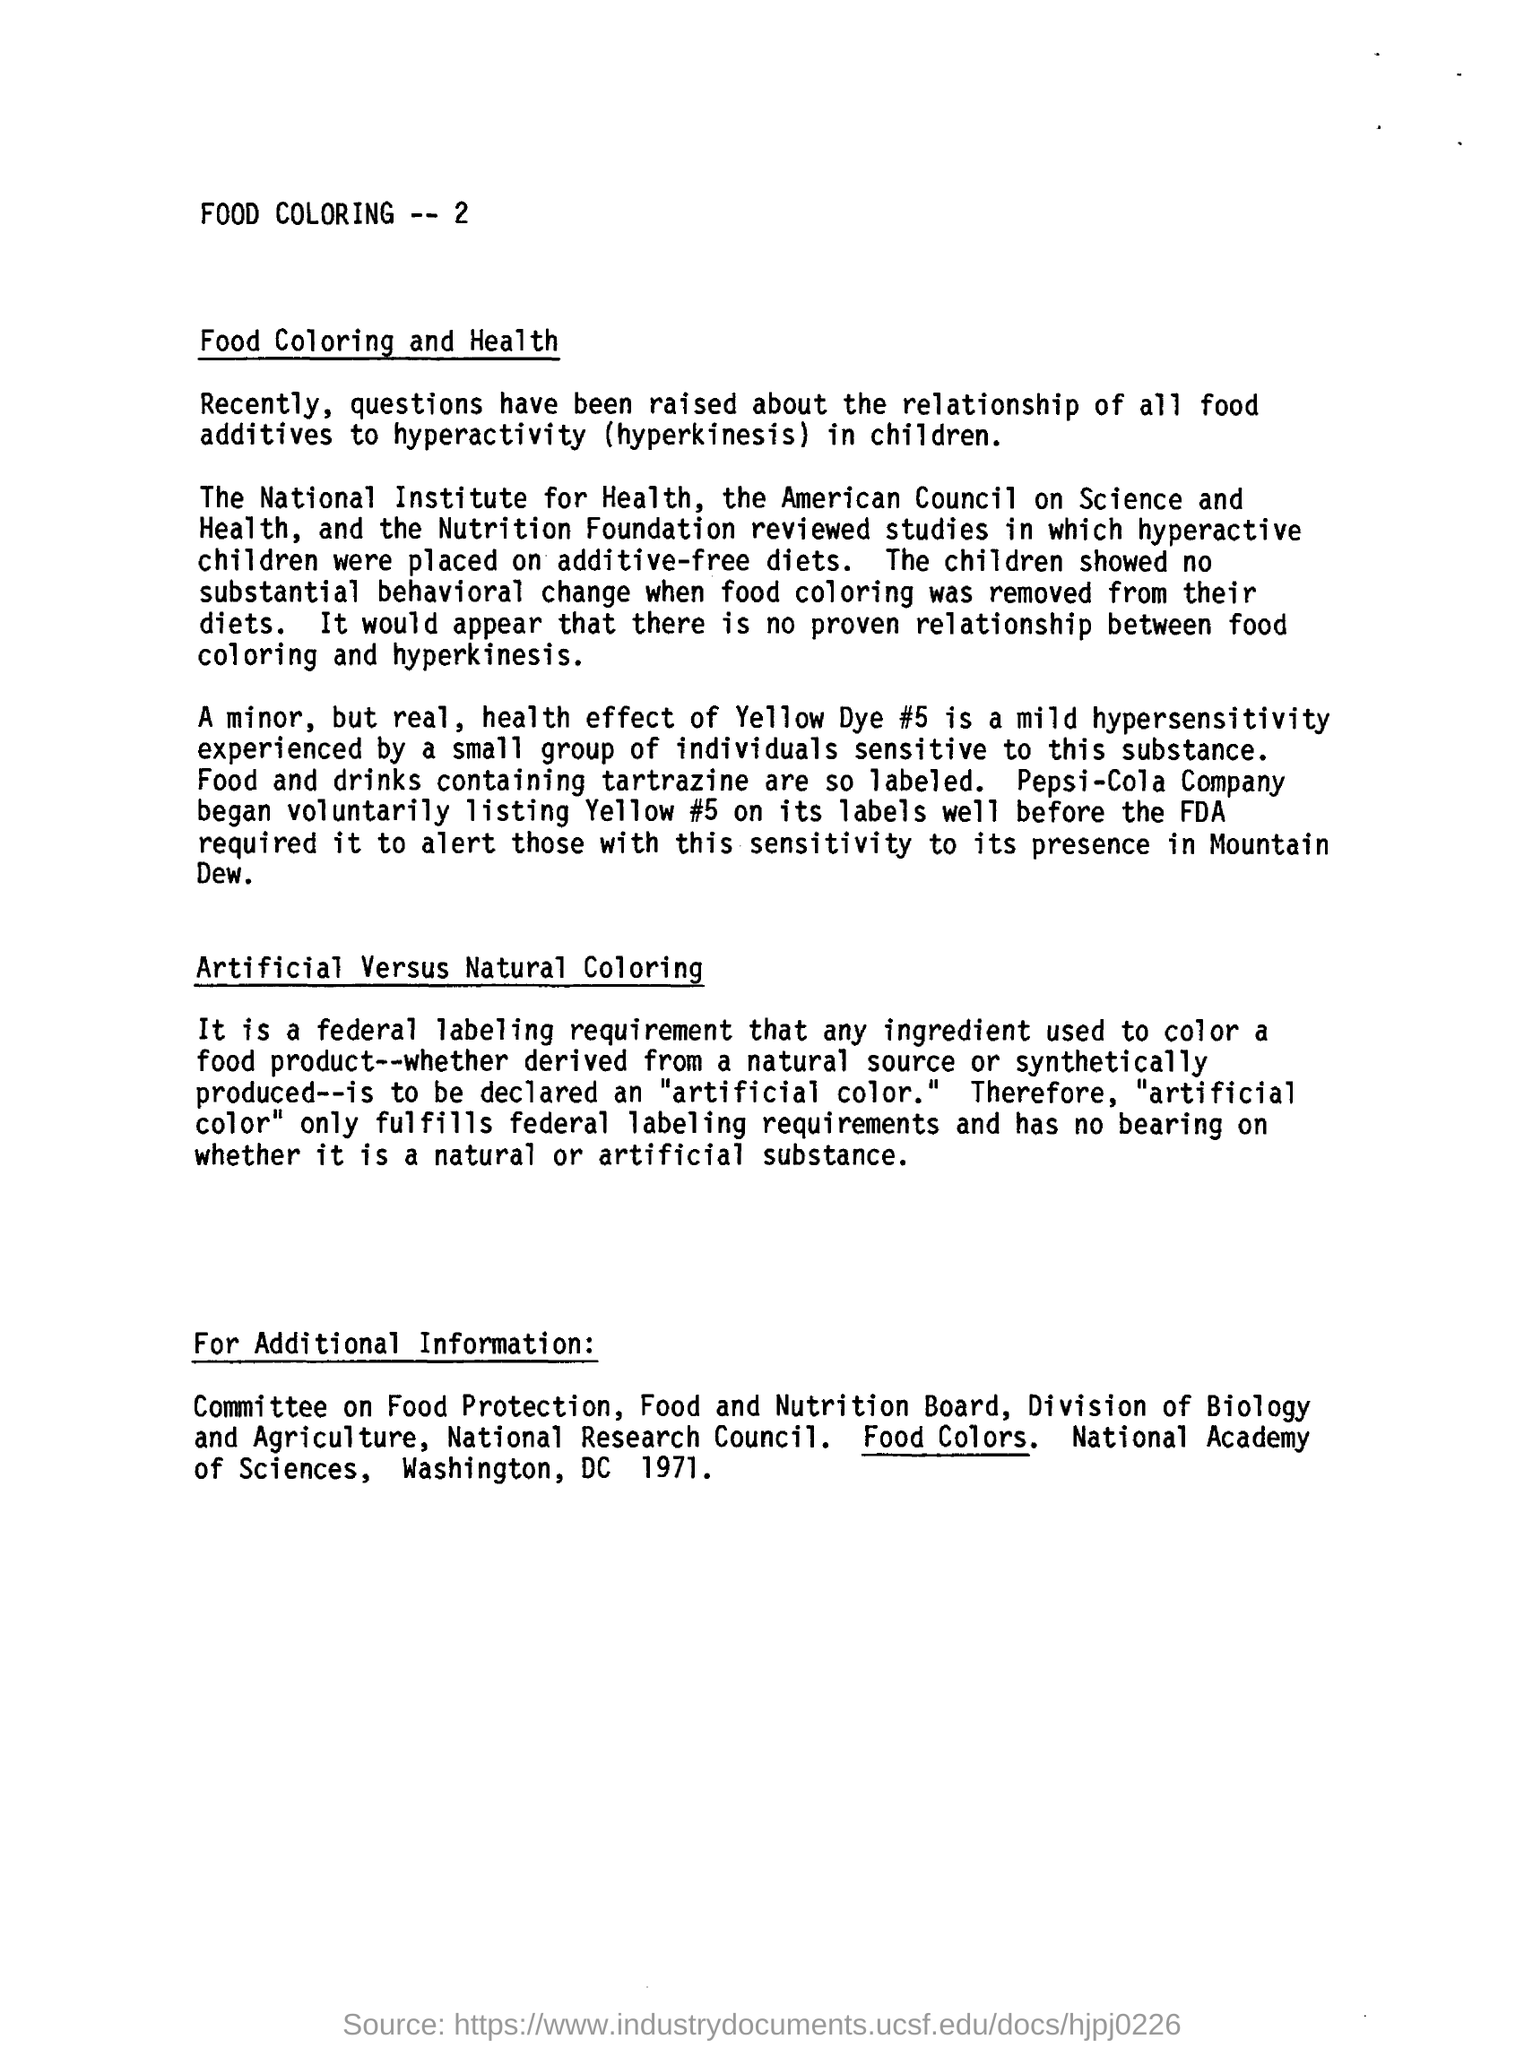Indicate a few pertinent items in this graphic. Artificial colorings are only fulfilled if they meet the labelling requirements set forth by the federal government. Pepsi-Cola Company was the first company to voluntarily list Yello #5 on its labels before the FDA required it. The removal of food coloring from the diets of hyperactive children was part of the study. 